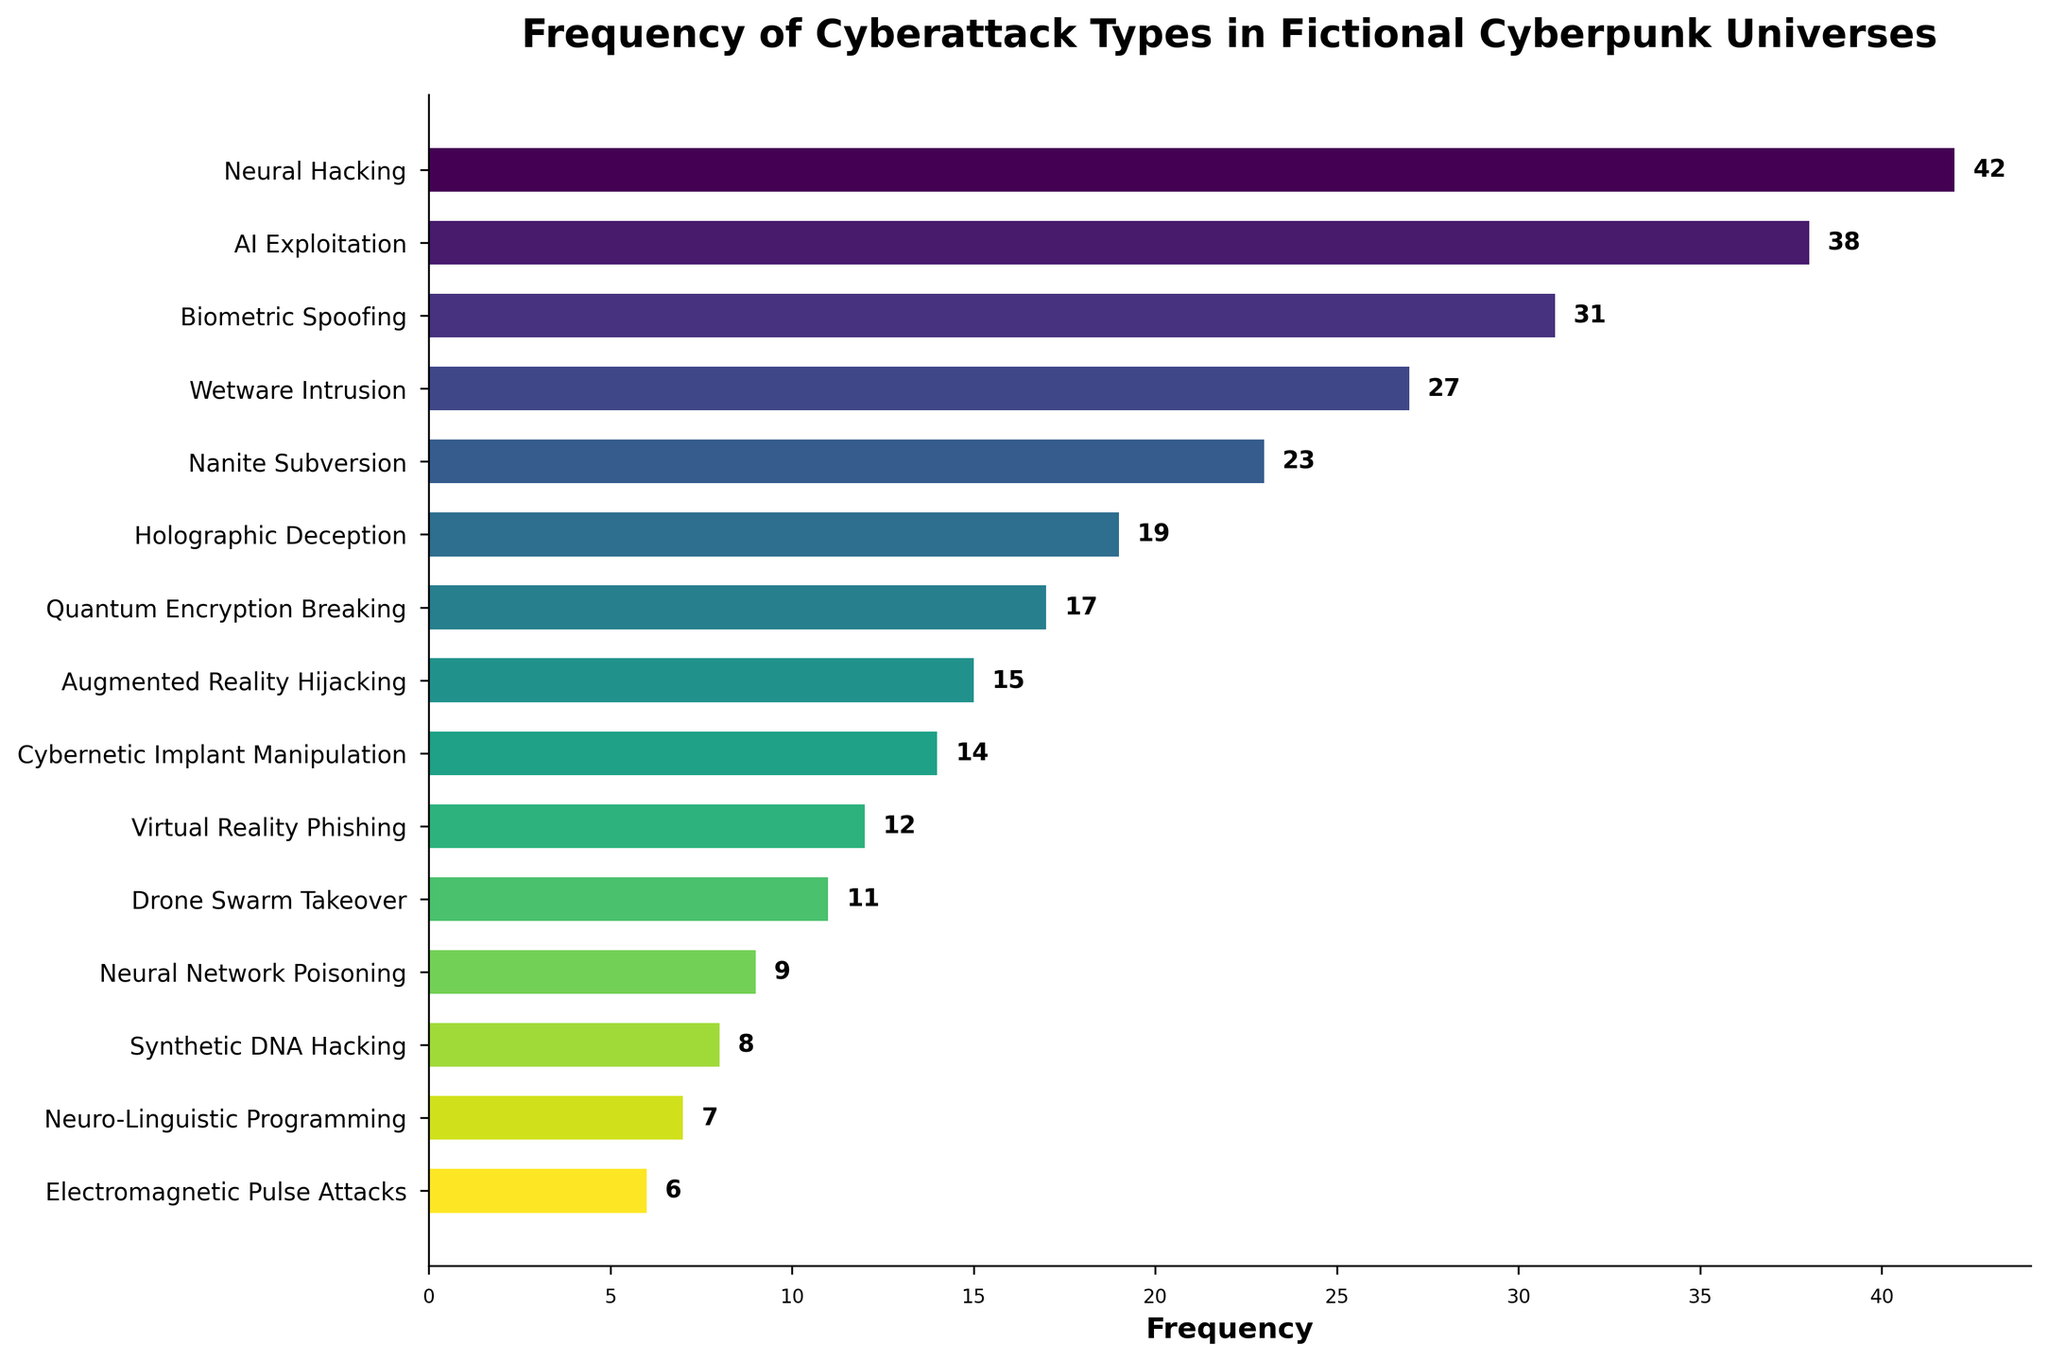What is the most frequent type of cyberattack in fictional cyberpunk universes? The bar corresponding to "Neural Hacking" is the tallest, indicating it has the highest frequency.
Answer: Neural Hacking Which cyberattack type has the lowest frequency? The bar corresponding to "Electromagnetic Pulse Attacks" is the shortest, which indicates the lowest frequency.
Answer: Electromagnetic Pulse Attacks How many more times does Neural Hacking occur compared to Electromagnetic Pulse Attacks? Neural Hacking occurs 42 times and Electromagnetic Pulse Attacks occur 6 times, so the difference is 42 - 6 = 36.
Answer: 36 Which cyberattack types have a frequency greater than 30 but less than 40? The bars corresponding to "Neural Hacking" (42) and "AI Exploitation" (38) are both above 30, while "Biometric Spoofing" (31) meets the criteria as well.
Answer: AI Exploitation, Biometric Spoofing What is the total frequency of the top three most frequent cyberattack types? Summing the frequencies of "Neural Hacking" (42), "AI Exploitation" (38), and "Biometric Spoofing" (31): 42 + 38 + 31 = 111.
Answer: 111 How many cyberattack types have a frequency less than or equal to 10? The bars for "Neural Network Poisoning" (9), "Synthetic DNA Hacking" (8), "Neuro-Linguistic Programming" (7), and "Electromagnetic Pulse Attacks" (6) all meet this criteria. Therefore, there are 4 such types.
Answer: 4 Between "Nanite Subversion" and "Holographic Deception", which has a higher frequency and by how much? "Nanite Subversion" has a frequency of 23, while "Holographic Deception" has a frequency of 19. The difference is 23 - 19 = 4.
Answer: Nanite Subversion by 4 Which cyberattack types are less frequent than "Drone Swarm Takeover"? The bars for "Neural Network Poisoning" (9), "Synthetic DNA Hacking" (8), "Neuro-Linguistic Programming" (7), and "Electromagnetic Pulse Attacks" (6) all have frequencies less than 11.
Answer: Neural Network Poisoning, Synthetic DNA Hacking, Neuro-Linguistic Programming, Electromagnetic Pulse Attacks What is the average frequency of the cyberattack types listed? Sum all frequencies and divide by the number of types. Total frequency = 42 + 38 + 31 + 27 + 23 + 19 + 17 + 15 + 14 + 12 + 11 + 9 + 8 + 7 + 6 = 279; there are 15 types, so average = 279 / 15 = 18.6.
Answer: 18.6 